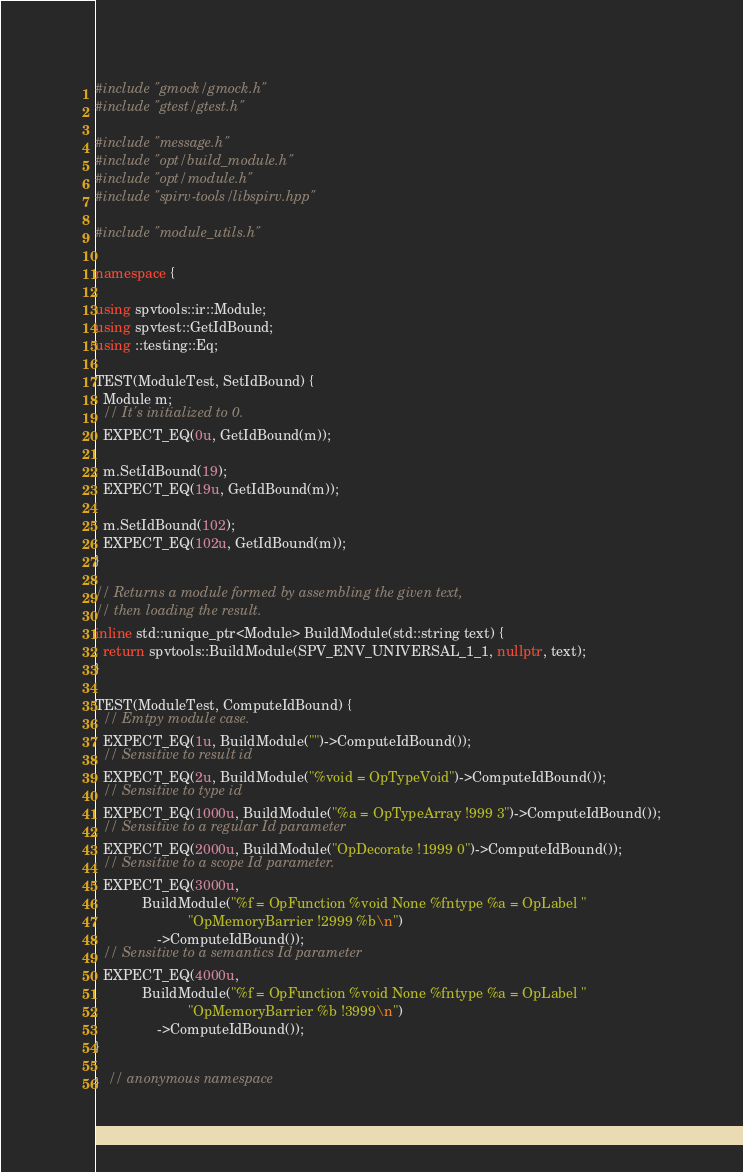Convert code to text. <code><loc_0><loc_0><loc_500><loc_500><_C++_>#include "gmock/gmock.h"
#include "gtest/gtest.h"

#include "message.h"
#include "opt/build_module.h"
#include "opt/module.h"
#include "spirv-tools/libspirv.hpp"

#include "module_utils.h"

namespace {

using spvtools::ir::Module;
using spvtest::GetIdBound;
using ::testing::Eq;

TEST(ModuleTest, SetIdBound) {
  Module m;
  // It's initialized to 0.
  EXPECT_EQ(0u, GetIdBound(m));

  m.SetIdBound(19);
  EXPECT_EQ(19u, GetIdBound(m));

  m.SetIdBound(102);
  EXPECT_EQ(102u, GetIdBound(m));
}

// Returns a module formed by assembling the given text,
// then loading the result.
inline std::unique_ptr<Module> BuildModule(std::string text) {
  return spvtools::BuildModule(SPV_ENV_UNIVERSAL_1_1, nullptr, text);
}

TEST(ModuleTest, ComputeIdBound) {
  // Emtpy module case.
  EXPECT_EQ(1u, BuildModule("")->ComputeIdBound());
  // Sensitive to result id
  EXPECT_EQ(2u, BuildModule("%void = OpTypeVoid")->ComputeIdBound());
  // Sensitive to type id
  EXPECT_EQ(1000u, BuildModule("%a = OpTypeArray !999 3")->ComputeIdBound());
  // Sensitive to a regular Id parameter
  EXPECT_EQ(2000u, BuildModule("OpDecorate !1999 0")->ComputeIdBound());
  // Sensitive to a scope Id parameter.
  EXPECT_EQ(3000u,
            BuildModule("%f = OpFunction %void None %fntype %a = OpLabel "
                        "OpMemoryBarrier !2999 %b\n")
                ->ComputeIdBound());
  // Sensitive to a semantics Id parameter
  EXPECT_EQ(4000u,
            BuildModule("%f = OpFunction %void None %fntype %a = OpLabel "
                        "OpMemoryBarrier %b !3999\n")
                ->ComputeIdBound());
}

}  // anonymous namespace
</code> 